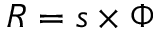Convert formula to latex. <formula><loc_0><loc_0><loc_500><loc_500>R = s \times \Phi</formula> 